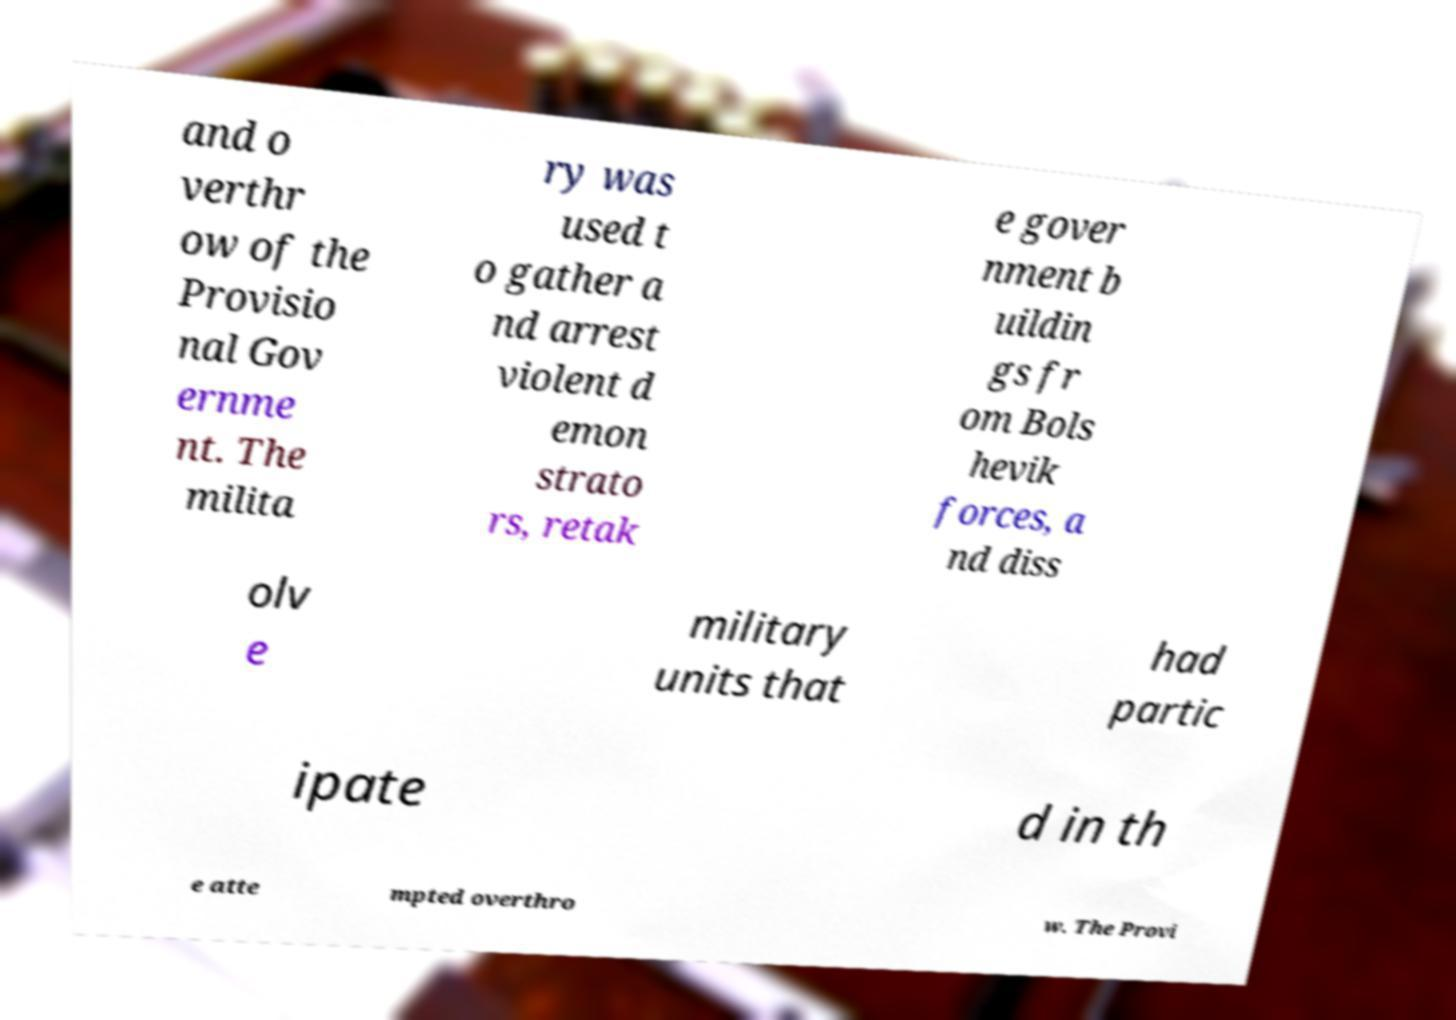Please read and relay the text visible in this image. What does it say? and o verthr ow of the Provisio nal Gov ernme nt. The milita ry was used t o gather a nd arrest violent d emon strato rs, retak e gover nment b uildin gs fr om Bols hevik forces, a nd diss olv e military units that had partic ipate d in th e atte mpted overthro w. The Provi 